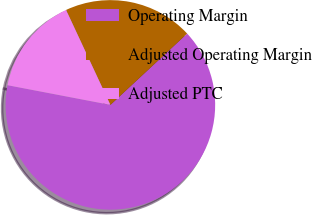<chart> <loc_0><loc_0><loc_500><loc_500><pie_chart><fcel>Operating Margin<fcel>Adjusted Operating Margin<fcel>Adjusted PTC<nl><fcel>64.92%<fcel>20.03%<fcel>15.04%<nl></chart> 